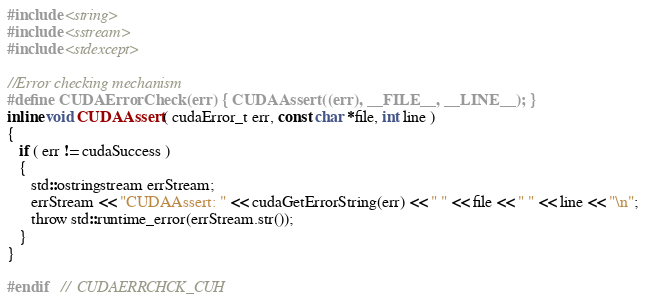<code> <loc_0><loc_0><loc_500><loc_500><_Cuda_>#include <string>
#include <sstream>
#include <stdexcept>

//Error checking mechanism
#define CUDAErrorCheck(err) { CUDAAssert((err), __FILE__, __LINE__); }
inline void CUDAAssert( cudaError_t err, const char *file, int line )
{
   if ( err != cudaSuccess )
   {
	  std::ostringstream errStream;
	  errStream << "CUDAAssert: " << cudaGetErrorString(err) << " " << file << " " << line << "\n";
      throw std::runtime_error(errStream.str());
   }
}

#endif	//	CUDAERRCHCK_CUH
</code> 